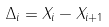<formula> <loc_0><loc_0><loc_500><loc_500>\Delta _ { i } = X _ { i } - X _ { i + 1 }</formula> 